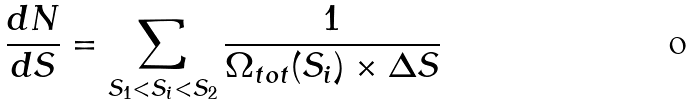Convert formula to latex. <formula><loc_0><loc_0><loc_500><loc_500>\frac { d N } { d S } = \sum _ { S _ { 1 } < S _ { i } < S _ { 2 } } \frac { 1 } { \Omega _ { t o t } ( S _ { i } ) \times \Delta S }</formula> 